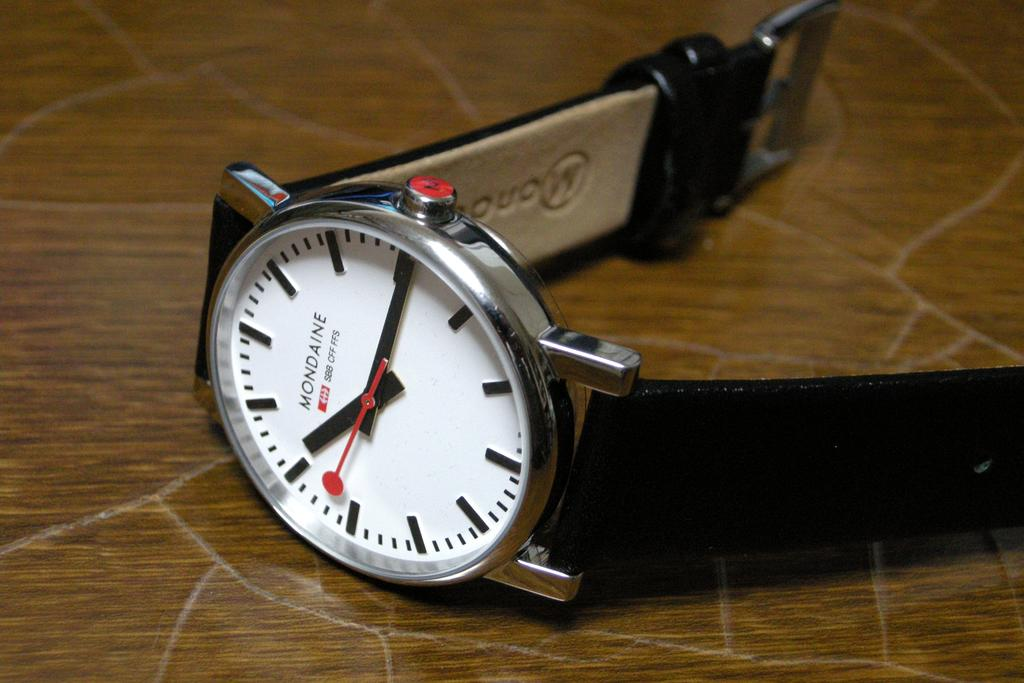<image>
Share a concise interpretation of the image provided. A Mondaine watch with a black ban and and white face showing the time of 10:15. 